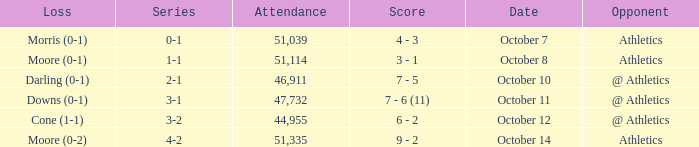When was the game with the loss of Moore (0-1)? October 8. 